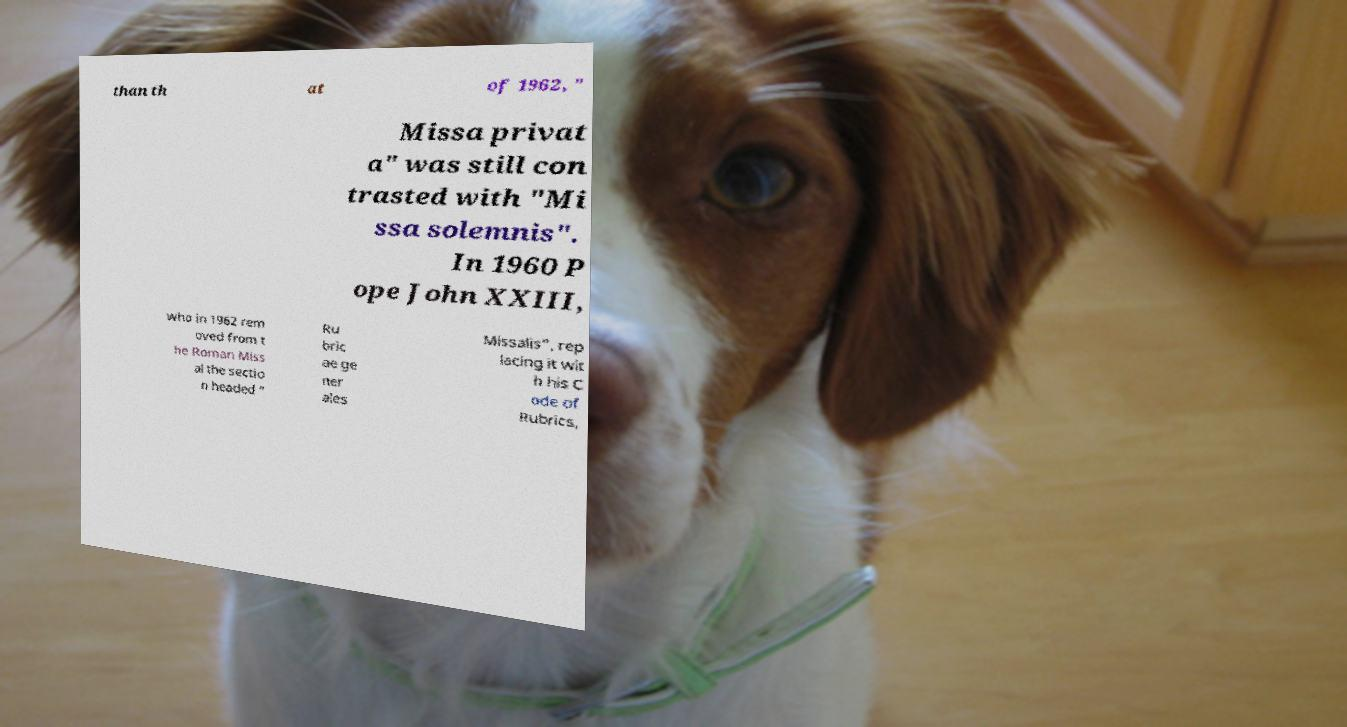I need the written content from this picture converted into text. Can you do that? than th at of 1962, " Missa privat a" was still con trasted with "Mi ssa solemnis". In 1960 P ope John XXIII, who in 1962 rem oved from t he Roman Miss al the sectio n headed " Ru bric ae ge ner ales Missalis", rep lacing it wit h his C ode of Rubrics, 